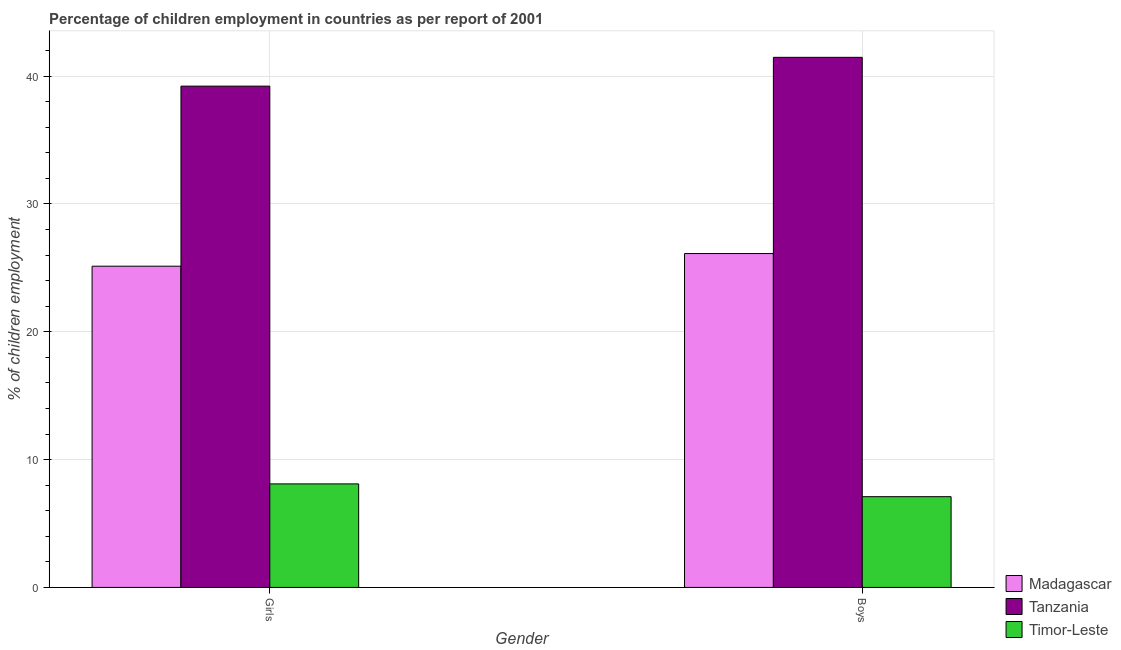How many groups of bars are there?
Offer a terse response. 2. Are the number of bars per tick equal to the number of legend labels?
Give a very brief answer. Yes. How many bars are there on the 2nd tick from the left?
Ensure brevity in your answer.  3. How many bars are there on the 2nd tick from the right?
Provide a short and direct response. 3. What is the label of the 1st group of bars from the left?
Make the answer very short. Girls. What is the percentage of employed girls in Tanzania?
Your answer should be very brief. 39.22. Across all countries, what is the maximum percentage of employed girls?
Offer a very short reply. 39.22. Across all countries, what is the minimum percentage of employed girls?
Your response must be concise. 8.1. In which country was the percentage of employed girls maximum?
Offer a terse response. Tanzania. In which country was the percentage of employed boys minimum?
Make the answer very short. Timor-Leste. What is the total percentage of employed boys in the graph?
Make the answer very short. 74.69. What is the difference between the percentage of employed girls in Madagascar and that in Timor-Leste?
Offer a very short reply. 17.03. What is the difference between the percentage of employed girls in Tanzania and the percentage of employed boys in Timor-Leste?
Your answer should be compact. 32.12. What is the average percentage of employed boys per country?
Your answer should be very brief. 24.9. What is the difference between the percentage of employed girls and percentage of employed boys in Madagascar?
Your response must be concise. -0.99. What is the ratio of the percentage of employed girls in Madagascar to that in Tanzania?
Your response must be concise. 0.64. Is the percentage of employed girls in Timor-Leste less than that in Tanzania?
Your answer should be compact. Yes. What does the 1st bar from the left in Girls represents?
Ensure brevity in your answer.  Madagascar. What does the 3rd bar from the right in Girls represents?
Give a very brief answer. Madagascar. How many countries are there in the graph?
Make the answer very short. 3. Does the graph contain any zero values?
Offer a very short reply. No. How many legend labels are there?
Your answer should be very brief. 3. What is the title of the graph?
Provide a short and direct response. Percentage of children employment in countries as per report of 2001. Does "Denmark" appear as one of the legend labels in the graph?
Your response must be concise. No. What is the label or title of the Y-axis?
Ensure brevity in your answer.  % of children employment. What is the % of children employment of Madagascar in Girls?
Your response must be concise. 25.13. What is the % of children employment of Tanzania in Girls?
Keep it short and to the point. 39.22. What is the % of children employment of Timor-Leste in Girls?
Offer a terse response. 8.1. What is the % of children employment in Madagascar in Boys?
Ensure brevity in your answer.  26.12. What is the % of children employment of Tanzania in Boys?
Ensure brevity in your answer.  41.47. What is the % of children employment of Timor-Leste in Boys?
Make the answer very short. 7.1. Across all Gender, what is the maximum % of children employment in Madagascar?
Provide a short and direct response. 26.12. Across all Gender, what is the maximum % of children employment in Tanzania?
Give a very brief answer. 41.47. Across all Gender, what is the minimum % of children employment of Madagascar?
Offer a terse response. 25.13. Across all Gender, what is the minimum % of children employment of Tanzania?
Give a very brief answer. 39.22. What is the total % of children employment of Madagascar in the graph?
Ensure brevity in your answer.  51.25. What is the total % of children employment of Tanzania in the graph?
Provide a succinct answer. 80.69. What is the total % of children employment in Timor-Leste in the graph?
Your response must be concise. 15.2. What is the difference between the % of children employment of Madagascar in Girls and that in Boys?
Give a very brief answer. -0.99. What is the difference between the % of children employment of Tanzania in Girls and that in Boys?
Ensure brevity in your answer.  -2.25. What is the difference between the % of children employment in Madagascar in Girls and the % of children employment in Tanzania in Boys?
Offer a terse response. -16.34. What is the difference between the % of children employment in Madagascar in Girls and the % of children employment in Timor-Leste in Boys?
Provide a short and direct response. 18.03. What is the difference between the % of children employment in Tanzania in Girls and the % of children employment in Timor-Leste in Boys?
Keep it short and to the point. 32.12. What is the average % of children employment in Madagascar per Gender?
Keep it short and to the point. 25.63. What is the average % of children employment in Tanzania per Gender?
Make the answer very short. 40.35. What is the average % of children employment of Timor-Leste per Gender?
Make the answer very short. 7.6. What is the difference between the % of children employment of Madagascar and % of children employment of Tanzania in Girls?
Keep it short and to the point. -14.09. What is the difference between the % of children employment in Madagascar and % of children employment in Timor-Leste in Girls?
Offer a terse response. 17.03. What is the difference between the % of children employment in Tanzania and % of children employment in Timor-Leste in Girls?
Offer a very short reply. 31.12. What is the difference between the % of children employment of Madagascar and % of children employment of Tanzania in Boys?
Make the answer very short. -15.35. What is the difference between the % of children employment in Madagascar and % of children employment in Timor-Leste in Boys?
Keep it short and to the point. 19.02. What is the difference between the % of children employment in Tanzania and % of children employment in Timor-Leste in Boys?
Ensure brevity in your answer.  34.37. What is the ratio of the % of children employment in Madagascar in Girls to that in Boys?
Ensure brevity in your answer.  0.96. What is the ratio of the % of children employment in Tanzania in Girls to that in Boys?
Your answer should be very brief. 0.95. What is the ratio of the % of children employment of Timor-Leste in Girls to that in Boys?
Make the answer very short. 1.14. What is the difference between the highest and the second highest % of children employment in Tanzania?
Your answer should be compact. 2.25. What is the difference between the highest and the second highest % of children employment of Timor-Leste?
Ensure brevity in your answer.  1. What is the difference between the highest and the lowest % of children employment of Madagascar?
Offer a very short reply. 0.99. What is the difference between the highest and the lowest % of children employment in Tanzania?
Offer a terse response. 2.25. 